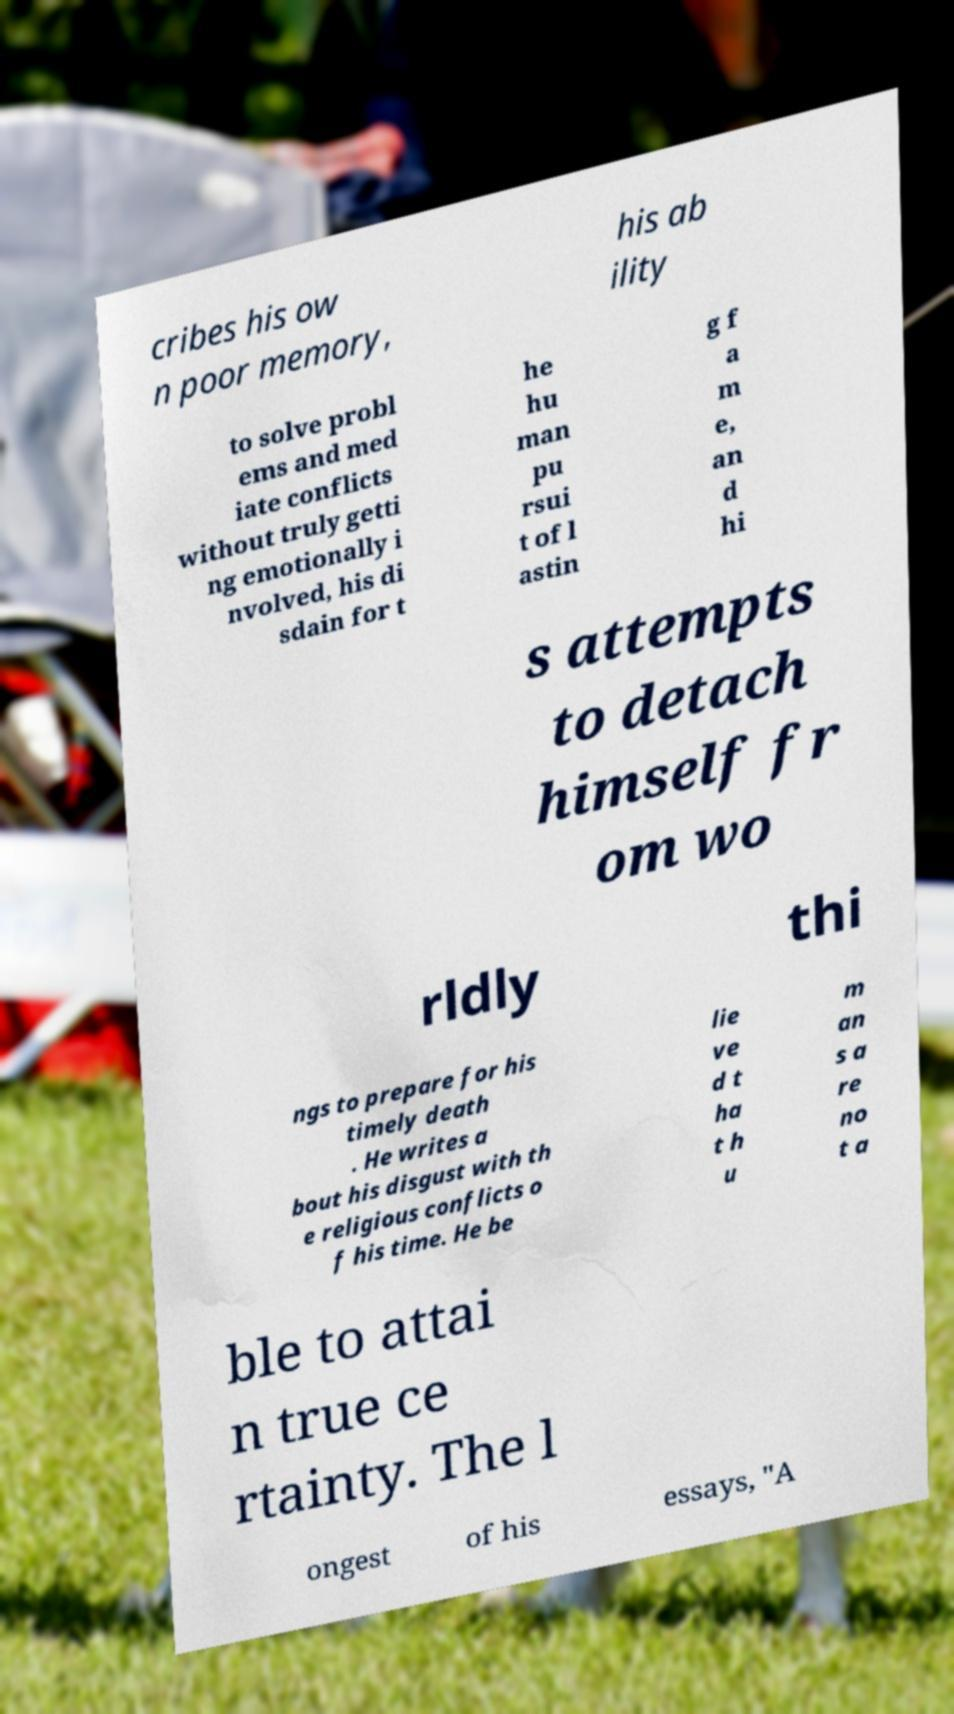Can you accurately transcribe the text from the provided image for me? cribes his ow n poor memory, his ab ility to solve probl ems and med iate conflicts without truly getti ng emotionally i nvolved, his di sdain for t he hu man pu rsui t of l astin g f a m e, an d hi s attempts to detach himself fr om wo rldly thi ngs to prepare for his timely death . He writes a bout his disgust with th e religious conflicts o f his time. He be lie ve d t ha t h u m an s a re no t a ble to attai n true ce rtainty. The l ongest of his essays, "A 